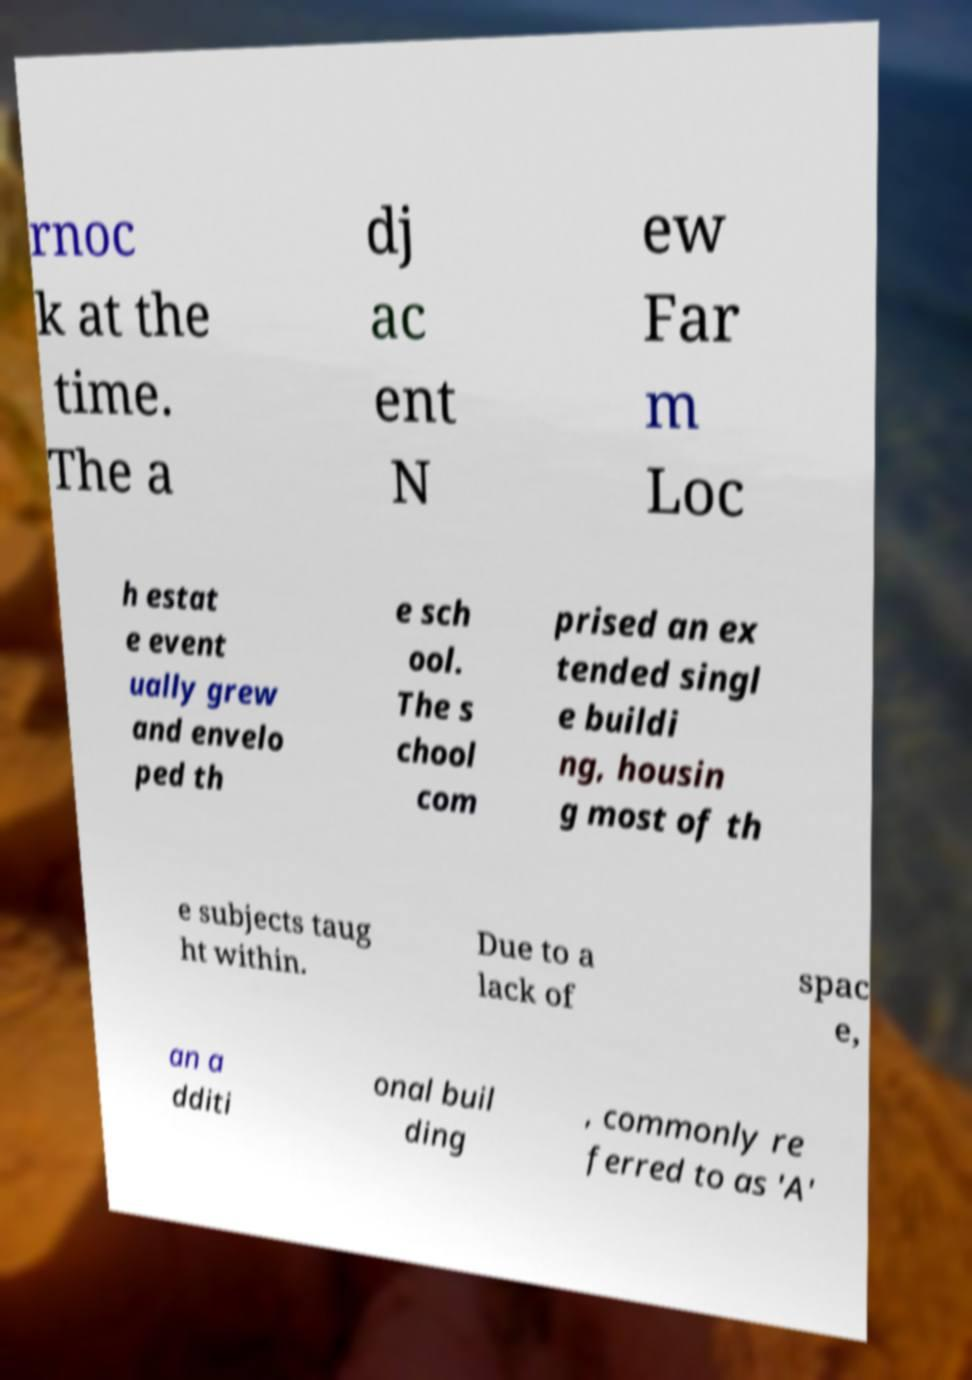Could you extract and type out the text from this image? rnoc k at the time. The a dj ac ent N ew Far m Loc h estat e event ually grew and envelo ped th e sch ool. The s chool com prised an ex tended singl e buildi ng, housin g most of th e subjects taug ht within. Due to a lack of spac e, an a dditi onal buil ding , commonly re ferred to as 'A' 